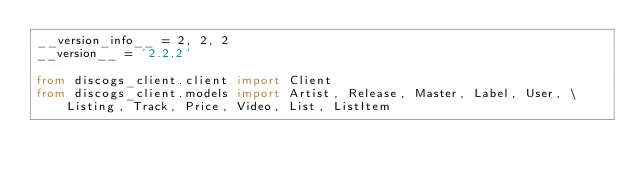<code> <loc_0><loc_0><loc_500><loc_500><_Python_>__version_info__ = 2, 2, 2
__version__ = '2.2.2'

from discogs_client.client import Client
from discogs_client.models import Artist, Release, Master, Label, User, \
    Listing, Track, Price, Video, List, ListItem
</code> 